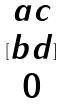<formula> <loc_0><loc_0><loc_500><loc_500>[ \begin{matrix} a c \\ b d \\ 0 \end{matrix} ]</formula> 